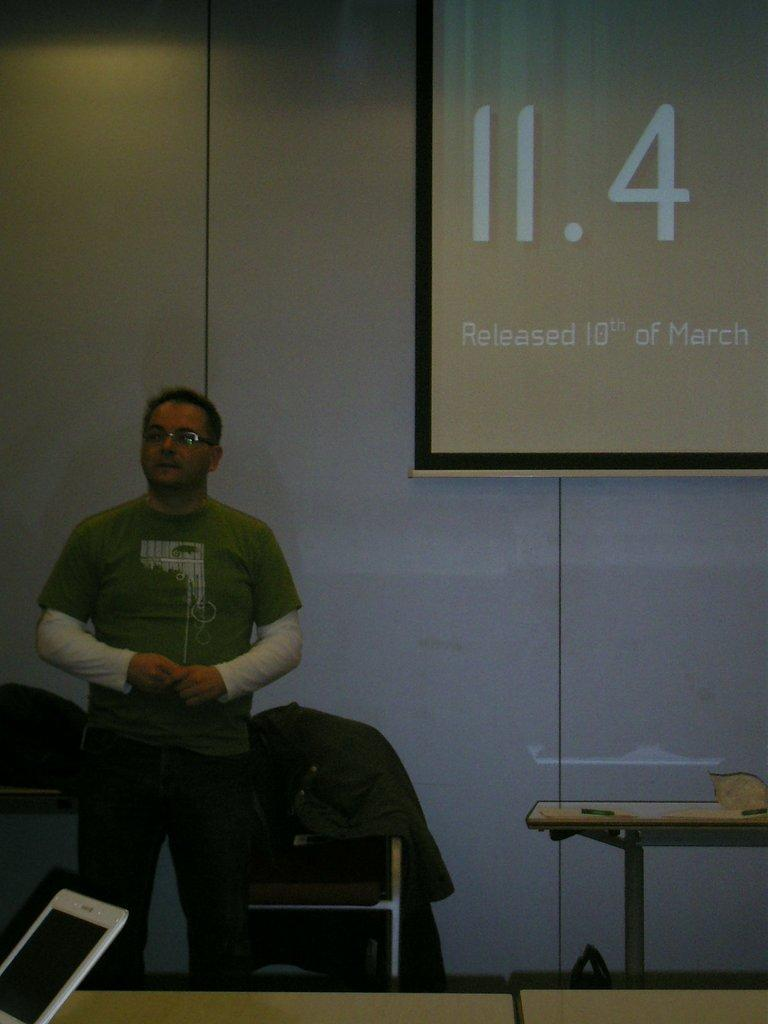What can be seen on the left side of the image? There is a person standing on the left side of the image. What piece of furniture is in the image? There is a table in the image. What electronic device is on the table? A laptop is present on the table. What is visible in the background of the image? There is a wall, a chair, and a jacket visible in the background of the image. What type of animals can be seen at the zoo in the image? There is no zoo present in the image; it features a person, a table, a laptop, and various items in the background. What advice might the person's grandmother give them in the image? There is no grandmother present in the image, so it is not possible to determine what advice she might give. 